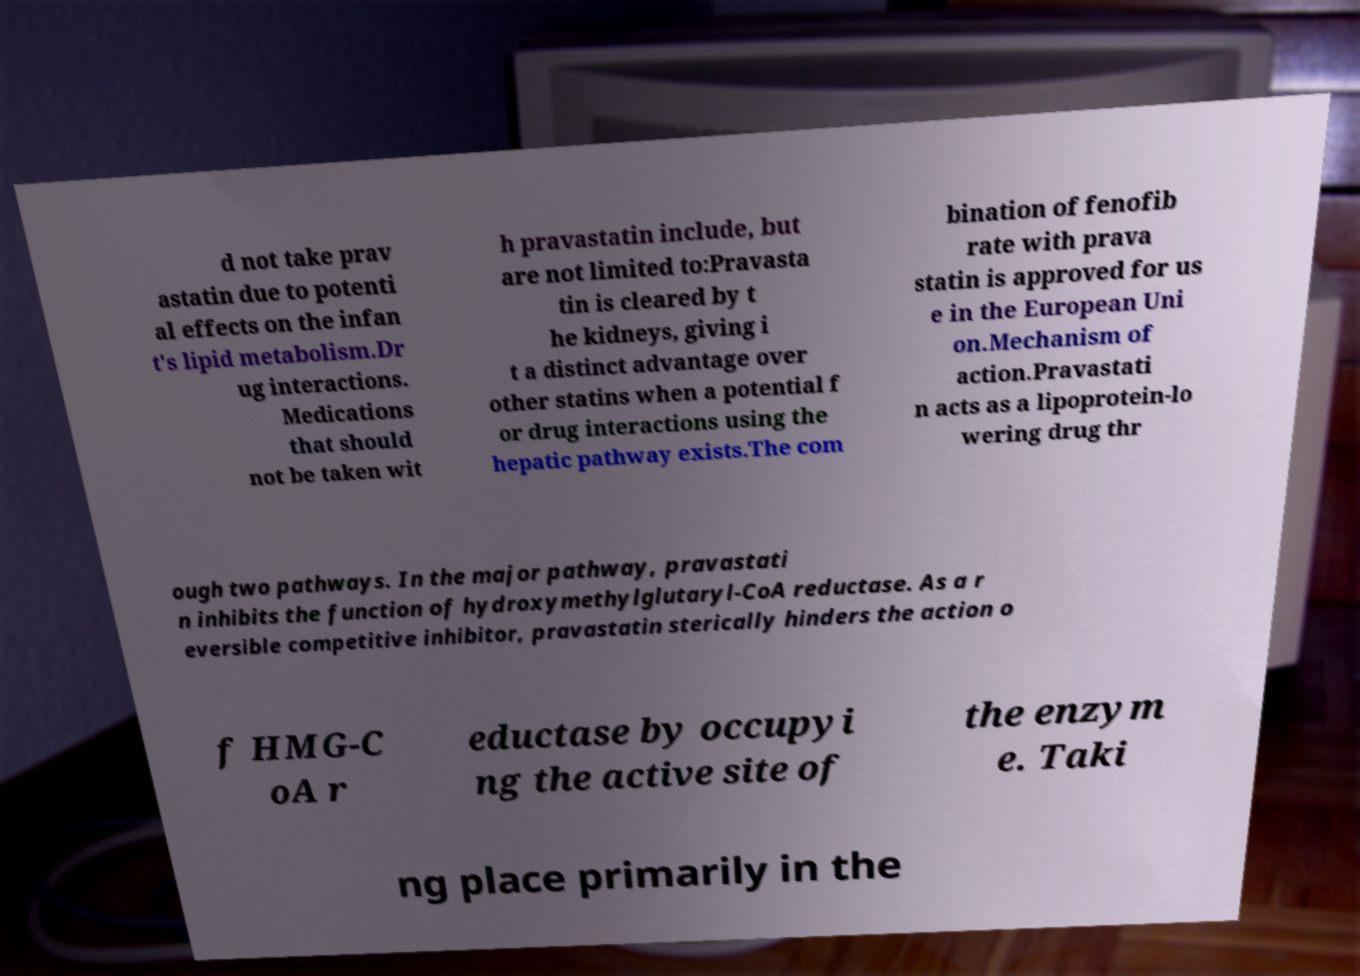There's text embedded in this image that I need extracted. Can you transcribe it verbatim? d not take prav astatin due to potenti al effects on the infan t's lipid metabolism.Dr ug interactions. Medications that should not be taken wit h pravastatin include, but are not limited to:Pravasta tin is cleared by t he kidneys, giving i t a distinct advantage over other statins when a potential f or drug interactions using the hepatic pathway exists.The com bination of fenofib rate with prava statin is approved for us e in the European Uni on.Mechanism of action.Pravastati n acts as a lipoprotein-lo wering drug thr ough two pathways. In the major pathway, pravastati n inhibits the function of hydroxymethylglutaryl-CoA reductase. As a r eversible competitive inhibitor, pravastatin sterically hinders the action o f HMG-C oA r eductase by occupyi ng the active site of the enzym e. Taki ng place primarily in the 